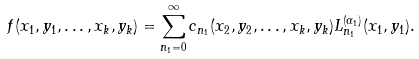Convert formula to latex. <formula><loc_0><loc_0><loc_500><loc_500>f ( x _ { 1 } , y _ { 1 } , \dots , x _ { k } , y _ { k } ) = \sum _ { n _ { 1 } = 0 } ^ { \infty } c _ { n _ { 1 } } ( x _ { 2 } , y _ { 2 } , \dots , x _ { k } , y _ { k } ) L _ { n _ { 1 } } ^ { ( \alpha _ { 1 } ) } ( x _ { 1 } , y _ { 1 } ) .</formula> 